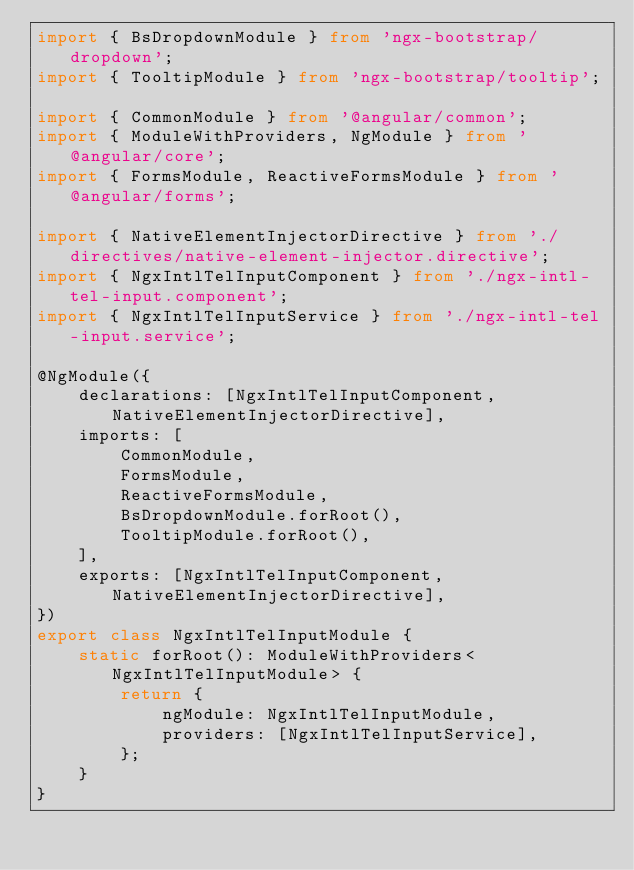Convert code to text. <code><loc_0><loc_0><loc_500><loc_500><_TypeScript_>import { BsDropdownModule } from 'ngx-bootstrap/dropdown';
import { TooltipModule } from 'ngx-bootstrap/tooltip';

import { CommonModule } from '@angular/common';
import { ModuleWithProviders, NgModule } from '@angular/core';
import { FormsModule, ReactiveFormsModule } from '@angular/forms';

import { NativeElementInjectorDirective } from './directives/native-element-injector.directive';
import { NgxIntlTelInputComponent } from './ngx-intl-tel-input.component';
import { NgxIntlTelInputService } from './ngx-intl-tel-input.service';

@NgModule({
	declarations: [NgxIntlTelInputComponent, NativeElementInjectorDirective],
	imports: [
		CommonModule,
		FormsModule,
		ReactiveFormsModule,
		BsDropdownModule.forRoot(),
		TooltipModule.forRoot(),
	],
	exports: [NgxIntlTelInputComponent, NativeElementInjectorDirective],
})
export class NgxIntlTelInputModule {
	static forRoot(): ModuleWithProviders<NgxIntlTelInputModule> {
		return {
			ngModule: NgxIntlTelInputModule,
			providers: [NgxIntlTelInputService],
		};
	}
}
</code> 